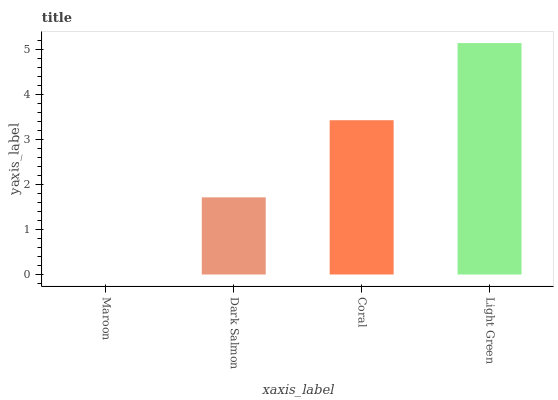Is Maroon the minimum?
Answer yes or no. Yes. Is Light Green the maximum?
Answer yes or no. Yes. Is Dark Salmon the minimum?
Answer yes or no. No. Is Dark Salmon the maximum?
Answer yes or no. No. Is Dark Salmon greater than Maroon?
Answer yes or no. Yes. Is Maroon less than Dark Salmon?
Answer yes or no. Yes. Is Maroon greater than Dark Salmon?
Answer yes or no. No. Is Dark Salmon less than Maroon?
Answer yes or no. No. Is Coral the high median?
Answer yes or no. Yes. Is Dark Salmon the low median?
Answer yes or no. Yes. Is Maroon the high median?
Answer yes or no. No. Is Coral the low median?
Answer yes or no. No. 